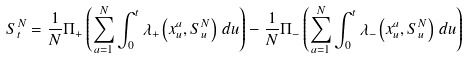Convert formula to latex. <formula><loc_0><loc_0><loc_500><loc_500>S ^ { N } _ { t } = \frac { 1 } { N } \Pi _ { + } \left ( \sum _ { a = 1 } ^ { N } \int _ { 0 } ^ { t } \lambda _ { + } \left ( x ^ { a } _ { u } , S ^ { N } _ { u } \right ) \, d u \right ) - \frac { 1 } { N } \Pi _ { - } \left ( \sum _ { a = 1 } ^ { N } \int _ { 0 } ^ { t } \lambda _ { - } \left ( x ^ { a } _ { u } , S ^ { N } _ { u } \right ) \, d u \right )</formula> 